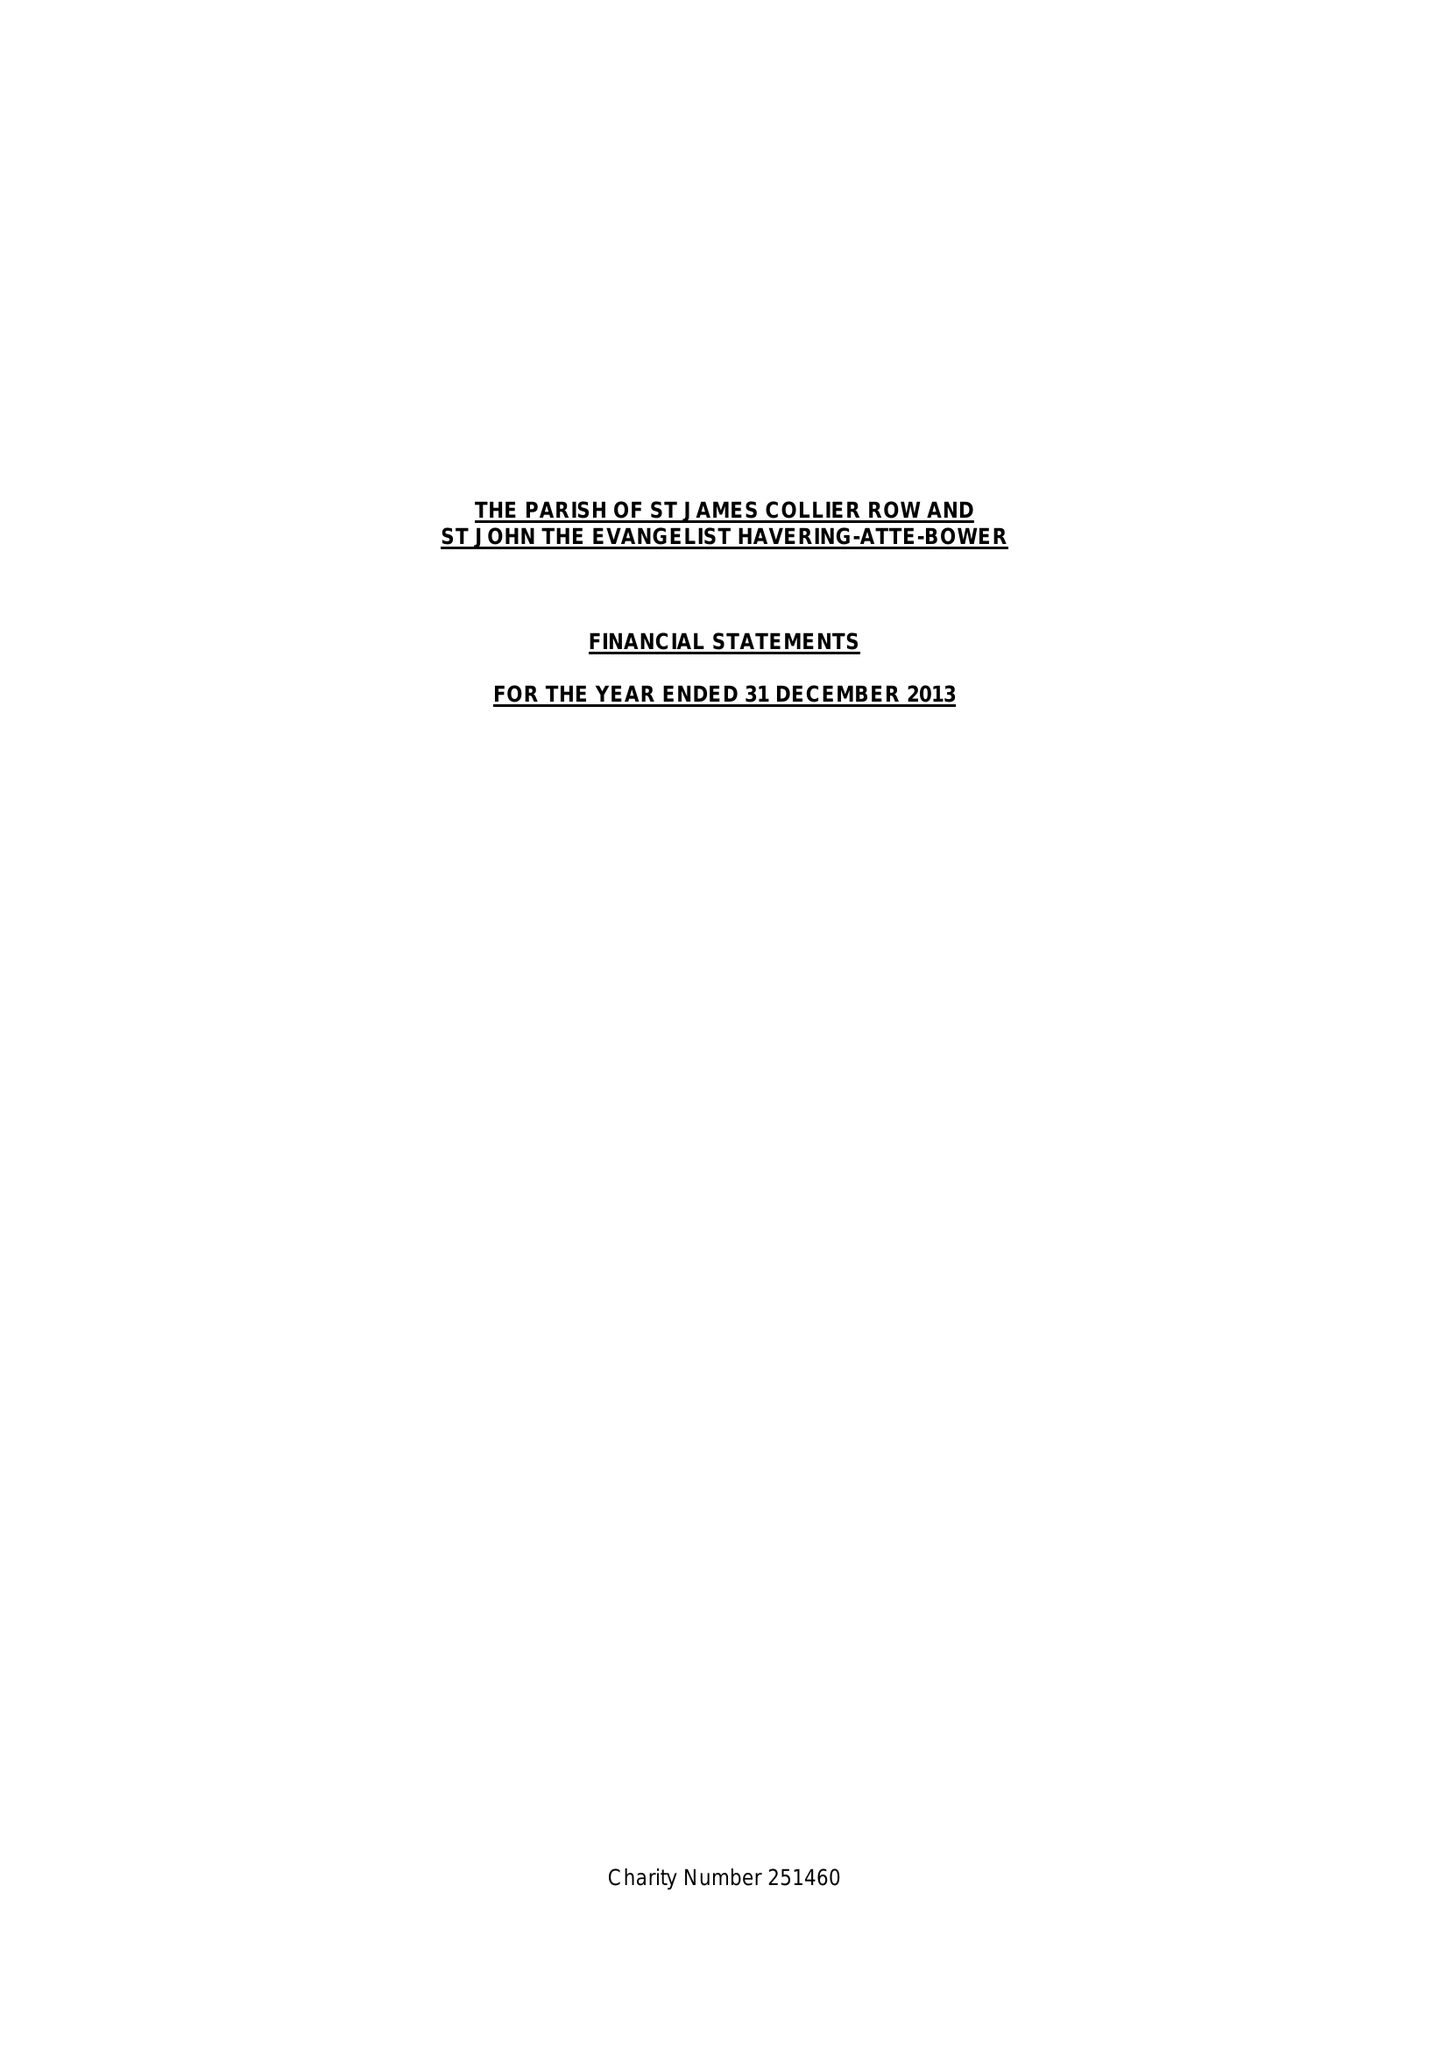What is the value for the report_date?
Answer the question using a single word or phrase. 2013-12-31 